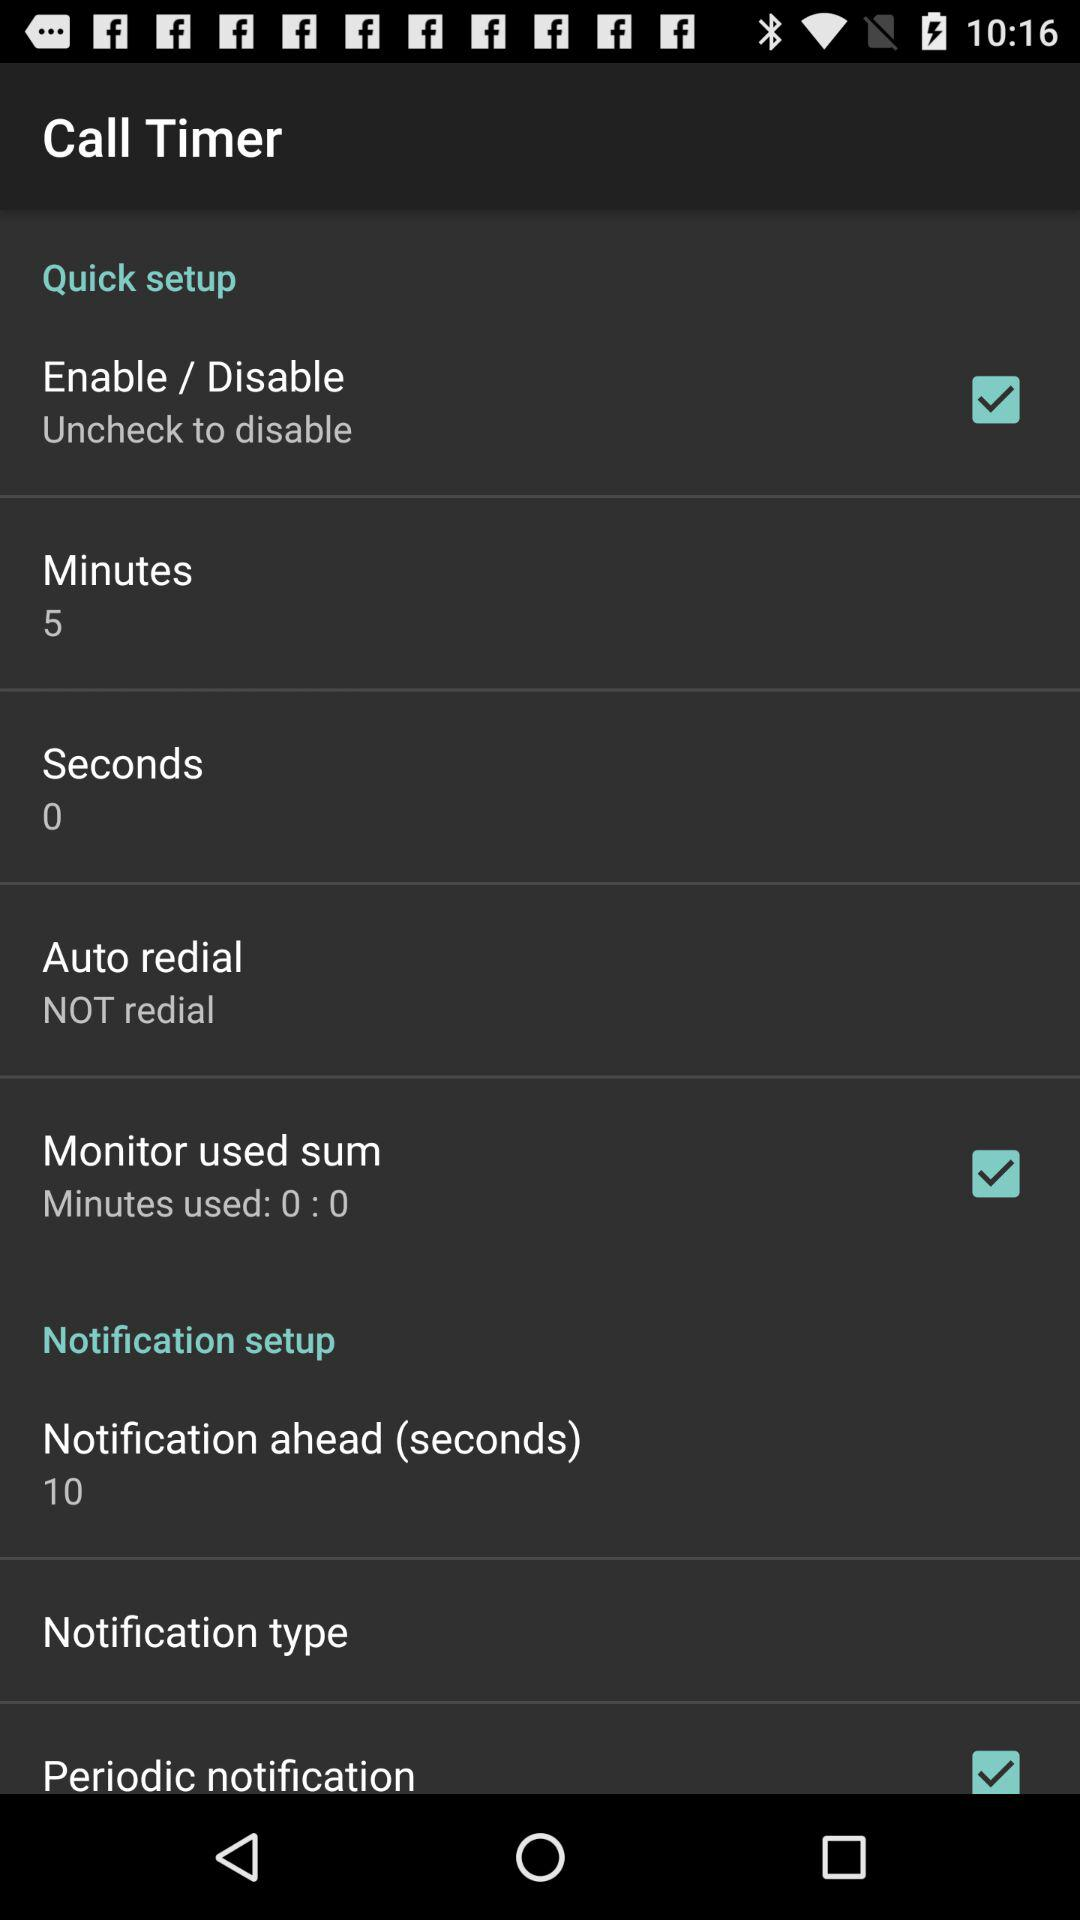What is the status of "Periodic notification"? The status is "on". 